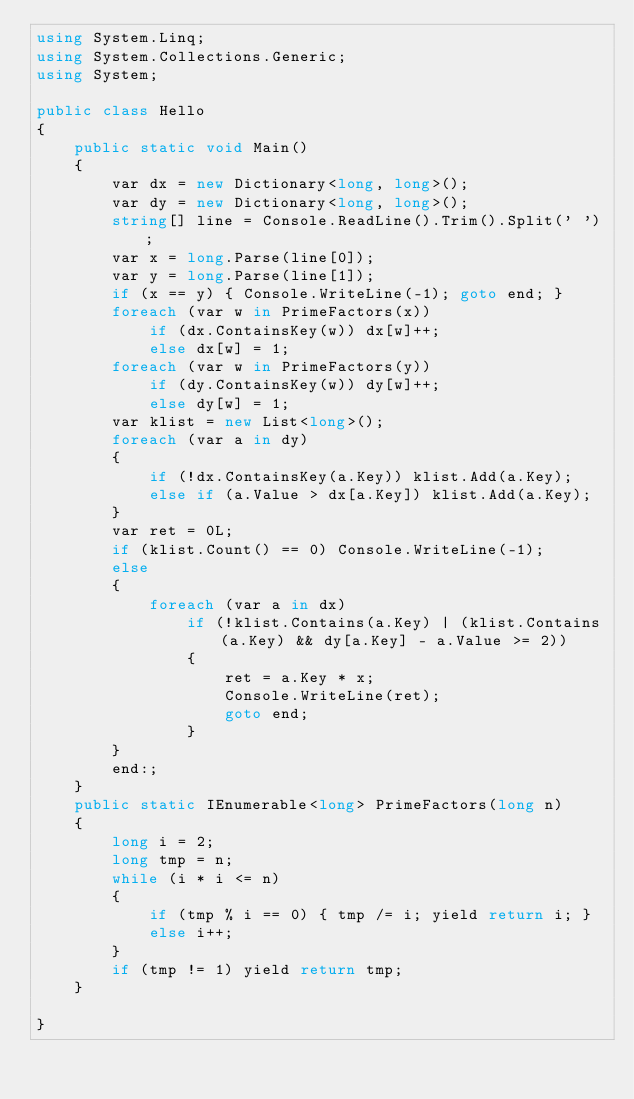<code> <loc_0><loc_0><loc_500><loc_500><_C#_>using System.Linq;
using System.Collections.Generic;
using System;

public class Hello
{
    public static void Main()
    {
        var dx = new Dictionary<long, long>();
        var dy = new Dictionary<long, long>();
        string[] line = Console.ReadLine().Trim().Split(' ');
        var x = long.Parse(line[0]);
        var y = long.Parse(line[1]);
        if (x == y) { Console.WriteLine(-1); goto end; }
        foreach (var w in PrimeFactors(x))
            if (dx.ContainsKey(w)) dx[w]++;
            else dx[w] = 1;
        foreach (var w in PrimeFactors(y))
            if (dy.ContainsKey(w)) dy[w]++;
            else dy[w] = 1;
        var klist = new List<long>();
        foreach (var a in dy)
        {
            if (!dx.ContainsKey(a.Key)) klist.Add(a.Key);
            else if (a.Value > dx[a.Key]) klist.Add(a.Key);
        }
        var ret = 0L;
        if (klist.Count() == 0) Console.WriteLine(-1);
        else
        {
            foreach (var a in dx)
                if (!klist.Contains(a.Key) | (klist.Contains(a.Key) && dy[a.Key] - a.Value >= 2))
                {
                    ret = a.Key * x;
                    Console.WriteLine(ret);
                    goto end;
                }
        }
        end:;
    }
    public static IEnumerable<long> PrimeFactors(long n)
    {
        long i = 2;
        long tmp = n;
        while (i * i <= n)
        {
            if (tmp % i == 0) { tmp /= i; yield return i; }
            else i++;
        }
        if (tmp != 1) yield return tmp;
    }

}
</code> 